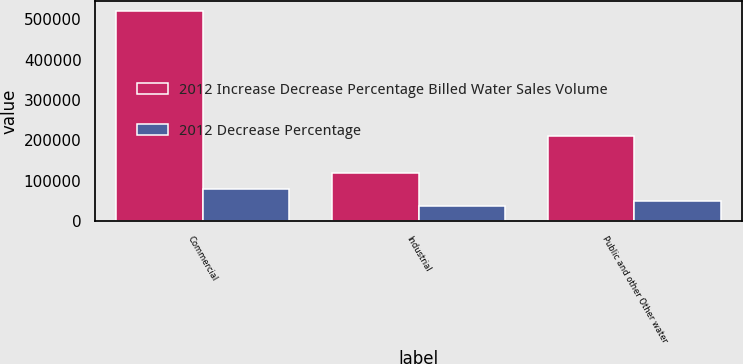Convert chart to OTSL. <chart><loc_0><loc_0><loc_500><loc_500><stacked_bar_chart><ecel><fcel>Commercial<fcel>Industrial<fcel>Public and other Other water<nl><fcel>2012 Increase Decrease Percentage Billed Water Sales Volume<fcel>520875<fcel>118939<fcel>211591<nl><fcel>2012 Decrease Percentage<fcel>80392<fcel>37107<fcel>51009<nl></chart> 